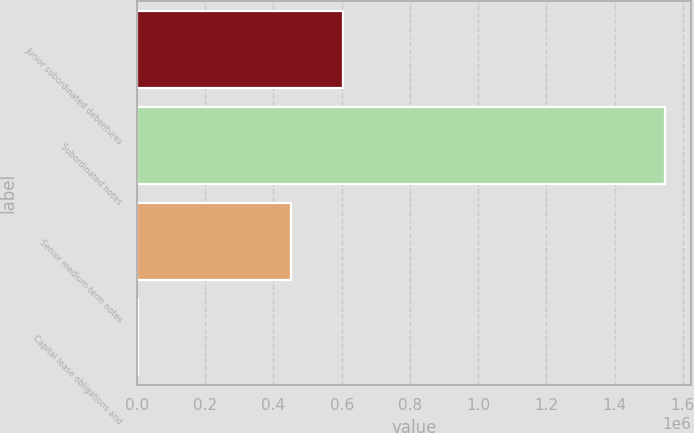Convert chart to OTSL. <chart><loc_0><loc_0><loc_500><loc_500><bar_chart><fcel>Junior subordinated debentures<fcel>Subordinated notes<fcel>Senior medium-term notes<fcel>Capital lease obligations and<nl><fcel>605144<fcel>1.54773e+06<fcel>450655<fcel>2839<nl></chart> 